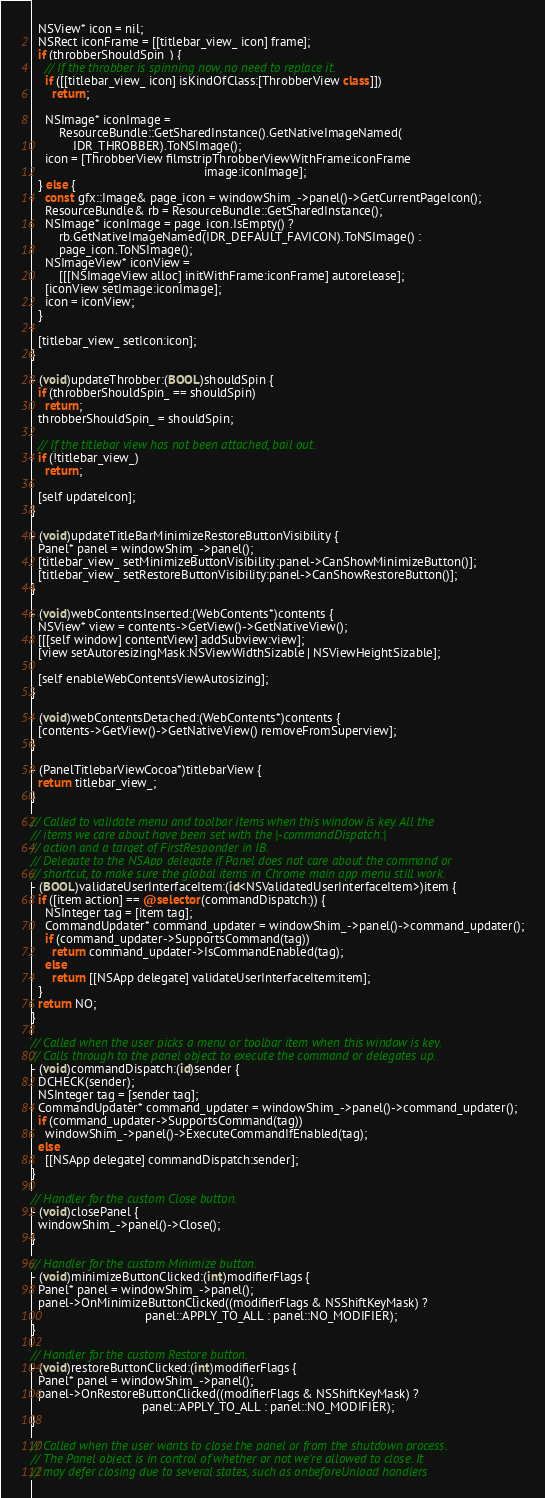Convert code to text. <code><loc_0><loc_0><loc_500><loc_500><_ObjectiveC_>  NSView* icon = nil;
  NSRect iconFrame = [[titlebar_view_ icon] frame];
  if (throbberShouldSpin_) {
    // If the throbber is spinning now, no need to replace it.
    if ([[titlebar_view_ icon] isKindOfClass:[ThrobberView class]])
      return;

    NSImage* iconImage =
        ResourceBundle::GetSharedInstance().GetNativeImageNamed(
            IDR_THROBBER).ToNSImage();
    icon = [ThrobberView filmstripThrobberViewWithFrame:iconFrame
                                                  image:iconImage];
  } else {
    const gfx::Image& page_icon = windowShim_->panel()->GetCurrentPageIcon();
    ResourceBundle& rb = ResourceBundle::GetSharedInstance();
    NSImage* iconImage = page_icon.IsEmpty() ?
        rb.GetNativeImageNamed(IDR_DEFAULT_FAVICON).ToNSImage() :
        page_icon.ToNSImage();
    NSImageView* iconView =
        [[[NSImageView alloc] initWithFrame:iconFrame] autorelease];
    [iconView setImage:iconImage];
    icon = iconView;
  }

  [titlebar_view_ setIcon:icon];
}

- (void)updateThrobber:(BOOL)shouldSpin {
  if (throbberShouldSpin_ == shouldSpin)
    return;
  throbberShouldSpin_ = shouldSpin;

  // If the titlebar view has not been attached, bail out.
  if (!titlebar_view_)
    return;

  [self updateIcon];
}

- (void)updateTitleBarMinimizeRestoreButtonVisibility {
  Panel* panel = windowShim_->panel();
  [titlebar_view_ setMinimizeButtonVisibility:panel->CanShowMinimizeButton()];
  [titlebar_view_ setRestoreButtonVisibility:panel->CanShowRestoreButton()];
}

- (void)webContentsInserted:(WebContents*)contents {
  NSView* view = contents->GetView()->GetNativeView();
  [[[self window] contentView] addSubview:view];
  [view setAutoresizingMask:NSViewWidthSizable | NSViewHeightSizable];

  [self enableWebContentsViewAutosizing];
}

- (void)webContentsDetached:(WebContents*)contents {
  [contents->GetView()->GetNativeView() removeFromSuperview];
}

- (PanelTitlebarViewCocoa*)titlebarView {
  return titlebar_view_;
}

// Called to validate menu and toolbar items when this window is key. All the
// items we care about have been set with the |-commandDispatch:|
// action and a target of FirstResponder in IB.
// Delegate to the NSApp delegate if Panel does not care about the command or
// shortcut, to make sure the global items in Chrome main app menu still work.
- (BOOL)validateUserInterfaceItem:(id<NSValidatedUserInterfaceItem>)item {
  if ([item action] == @selector(commandDispatch:)) {
    NSInteger tag = [item tag];
    CommandUpdater* command_updater = windowShim_->panel()->command_updater();
    if (command_updater->SupportsCommand(tag))
      return command_updater->IsCommandEnabled(tag);
    else
      return [[NSApp delegate] validateUserInterfaceItem:item];
  }
  return NO;
}

// Called when the user picks a menu or toolbar item when this window is key.
// Calls through to the panel object to execute the command or delegates up.
- (void)commandDispatch:(id)sender {
  DCHECK(sender);
  NSInteger tag = [sender tag];
  CommandUpdater* command_updater = windowShim_->panel()->command_updater();
  if (command_updater->SupportsCommand(tag))
    windowShim_->panel()->ExecuteCommandIfEnabled(tag);
  else
    [[NSApp delegate] commandDispatch:sender];
}

// Handler for the custom Close button.
- (void)closePanel {
  windowShim_->panel()->Close();
}

// Handler for the custom Minimize button.
- (void)minimizeButtonClicked:(int)modifierFlags {
  Panel* panel = windowShim_->panel();
  panel->OnMinimizeButtonClicked((modifierFlags & NSShiftKeyMask) ?
                                 panel::APPLY_TO_ALL : panel::NO_MODIFIER);
}

// Handler for the custom Restore button.
- (void)restoreButtonClicked:(int)modifierFlags {
  Panel* panel = windowShim_->panel();
  panel->OnRestoreButtonClicked((modifierFlags & NSShiftKeyMask) ?
                                panel::APPLY_TO_ALL : panel::NO_MODIFIER);
}

// Called when the user wants to close the panel or from the shutdown process.
// The Panel object is in control of whether or not we're allowed to close. It
// may defer closing due to several states, such as onbeforeUnload handlers</code> 